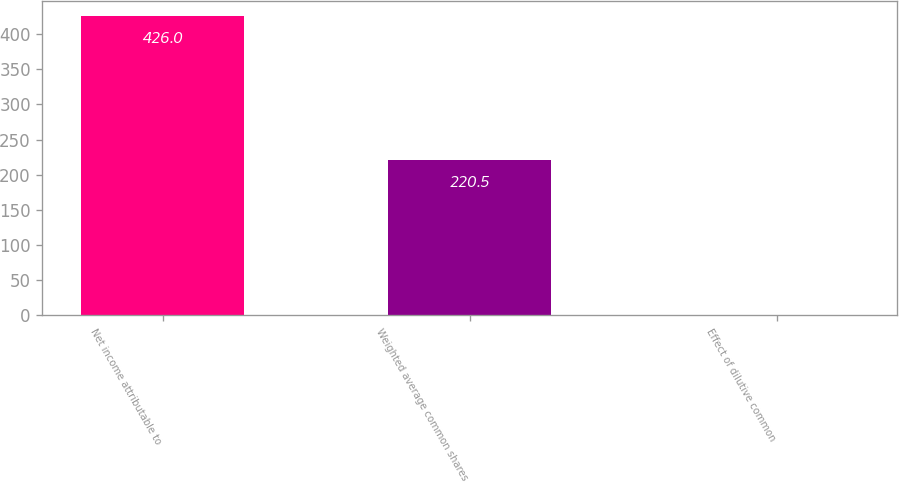Convert chart. <chart><loc_0><loc_0><loc_500><loc_500><bar_chart><fcel>Net income attributable to<fcel>Weighted average common shares<fcel>Effect of dilutive common<nl><fcel>426<fcel>220.5<fcel>1<nl></chart> 